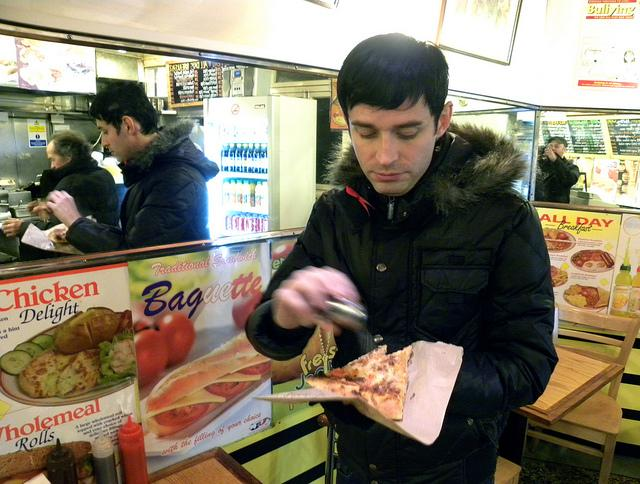What is he doing with the pizza? Please explain your reasoning. adding flavor. The other options don't match this image at all. 